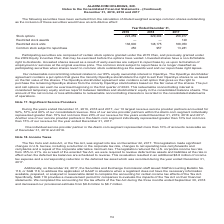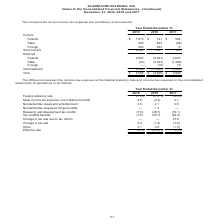According to Alarmcom Holdings's financial document, When was the The Tax Cuts and Jobs Act, or the Tax Act, signed into law? According to the financial document, December 22, 2017. The relevant text states: "Jobs Act, or the Tax Act, was signed into law on December 22, 2017. This legislation made significant changes in U.S. tax law, including a reduction in the corporate..." Also, Which years does the table provide information for the components of the company's income tax expense? The document contains multiple relevant values: 2019, 2018, 2017. From the document: "Year Ended December 31, 2019 2018 2017 Stock options 223,259 229,294 258,917 Restricted stock awards — — 129 Restricted stock units 136,60 Year Ended ..." Also, What was the total income tax expense in 2019? According to the financial document, 5,566 (in thousands). The relevant text states: "8) 19 Total Deferred 2,599 (11,482) 2,488 Total $ 5,566 $ (9,825) $ 2,990..." Also, can you calculate: What was the change in current State income tax expense between 2018 and 2019? Based on the calculation: 900-653, the result is 247 (in thousands). This is based on the information: "18 2017 Current Federal $ 1,615 $ 741 $ 584 State 900 653 (88) Foreign 452 263 6 Total Current 2,967 1,657 502 Deferred Federal 2,622 (8,821) 3,837 State 017 Current Federal $ 1,615 $ 741 $ 584 State ..." The key data points involved are: 653, 900. Also, can you calculate: What was the change in total deferred income tax expense between 2017 and 2019? Based on the calculation: 2,599-2,488, the result is 111 (in thousands). This is based on the information: "(2,643) (1,368) Foreign — (18) 19 Total Deferred 2,599 (11,482) 2,488 Total $ 5,566 $ (9,825) $ 2,990 ) Foreign — (18) 19 Total Deferred 2,599 (11,482) 2,488 Total $ 5,566 $ (9,825) $ 2,990..." The key data points involved are: 2,488, 2,599. Also, can you calculate: What was the percentage change in the total income tax expense between 2017 and 2019? To answer this question, I need to perform calculations using the financial data. The calculation is: (5,566-2,990)/2,990, which equals 86.15 (percentage). This is based on the information: "8) 19 Total Deferred 2,599 (11,482) 2,488 Total $ 5,566 $ (9,825) $ 2,990 ed 2,599 (11,482) 2,488 Total $ 5,566 $ (9,825) $ 2,990..." The key data points involved are: 2,990, 5,566. 